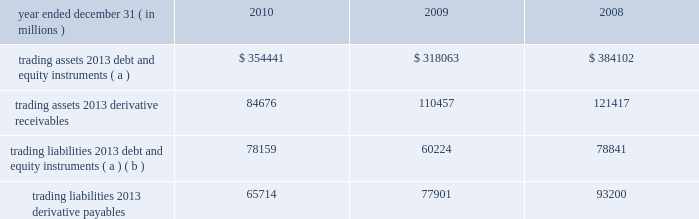Jpmorgan chase & co./2010 annual report 187 trading assets and liabilities trading assets include debt and equity instruments held for trading purposes that jpmorgan chase owns ( 201clong 201d positions ) , certain loans managed on a fair value basis and for which the firm has elected the fair value option , and physical commodities inventories that are generally accounted for at the lower of cost or fair value .
Trading liabilities include debt and equity instruments that the firm has sold to other parties but does not own ( 201cshort 201d positions ) .
The firm is obligated to purchase instruments at a future date to cover the short positions .
Included in trading assets and trading liabilities are the reported receivables ( unrealized gains ) and payables ( unre- alized losses ) related to derivatives .
Trading assets and liabilities are carried at fair value on the consolidated balance sheets .
Bal- ances reflect the reduction of securities owned ( long positions ) by the amount of securities sold but not yet purchased ( short posi- tions ) when the long and short positions have identical committee on uniform security identification procedures ( 201ccusips 201d ) .
Trading assets and liabilities 2013average balances average trading assets and liabilities were as follows for the periods indicated. .
( a ) balances reflect the reduction of securities owned ( long positions ) by the amount of securities sold , but not yet purchased ( short positions ) when the long and short positions have identical cusips .
( b ) primarily represent securities sold , not yet purchased .
Note 4 2013 fair value option the fair value option provides an option to elect fair value as an alternative measurement for selected financial assets , financial liabilities , unrecognized firm commitments , and written loan com- mitments not previously carried at fair value .
Elections elections were made by the firm to : 2022 mitigate income statement volatility caused by the differences in the measurement basis of elected instruments ( for example , cer- tain instruments elected were previously accounted for on an accrual basis ) while the associated risk management arrange- ments are accounted for on a fair value basis ; 2022 eliminate the complexities of applying certain accounting models ( e.g. , hedge accounting or bifurcation accounting for hybrid in- struments ) ; and 2022 better reflect those instruments that are managed on a fair value basis .
Elections include the following : 2022 loans purchased or originated as part of securitization ware- housing activity , subject to bifurcation accounting , or man- aged on a fair value basis .
2022 securities financing arrangements with an embedded deriva- tive and/or a maturity of greater than one year .
2022 owned beneficial interests in securitized financial assets that contain embedded credit derivatives , which would otherwise be required to be separately accounted for as a derivative in- strument .
2022 certain tax credits and other equity investments acquired as part of the washington mutual transaction .
2022 structured notes issued as part of ib 2019s client-driven activities .
( structured notes are financial instruments that contain em- bedded derivatives. ) 2022 long-term beneficial interests issued by ib 2019s consolidated securitization trusts where the underlying assets are carried at fair value. .
What is the 2020 net derivative balance in billions? 
Computations: (84676 - 65714)
Answer: 18962.0. 